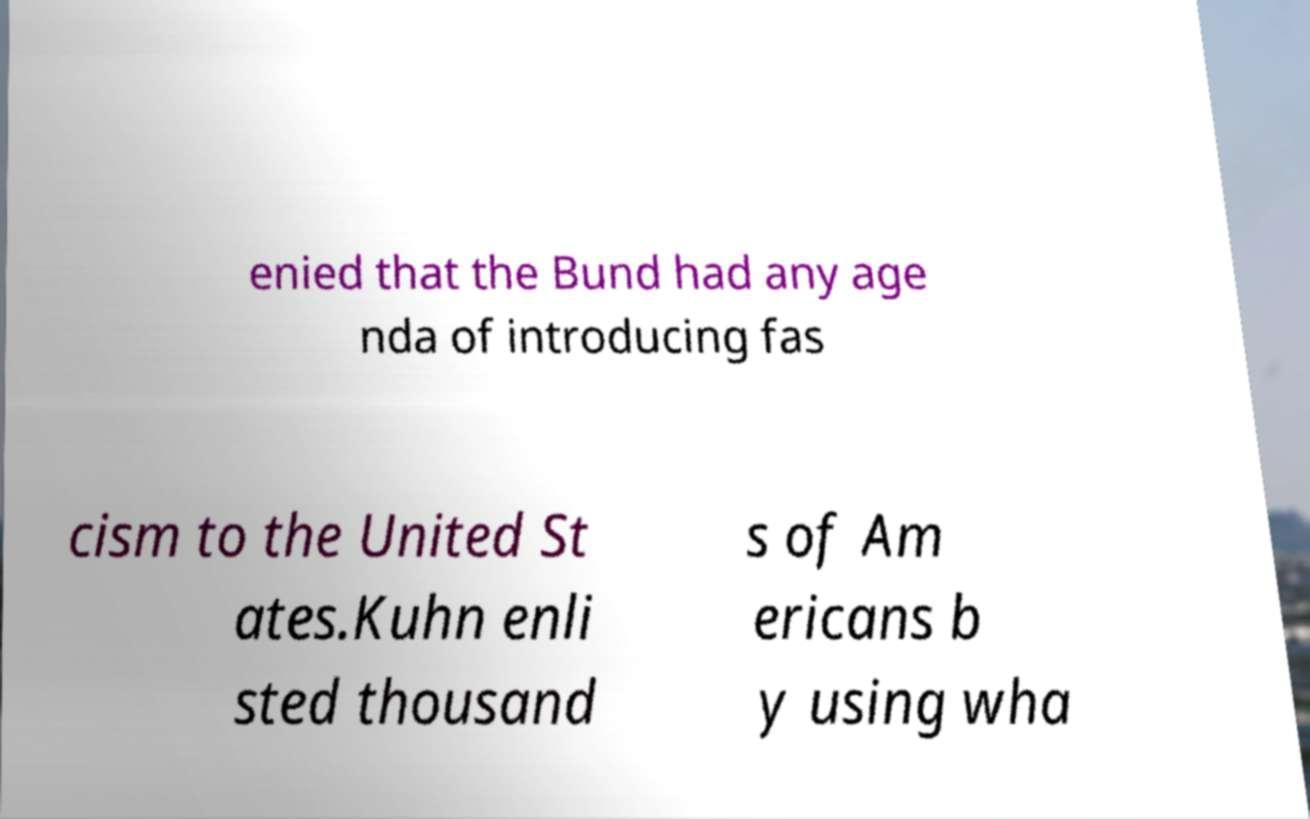What messages or text are displayed in this image? I need them in a readable, typed format. enied that the Bund had any age nda of introducing fas cism to the United St ates.Kuhn enli sted thousand s of Am ericans b y using wha 